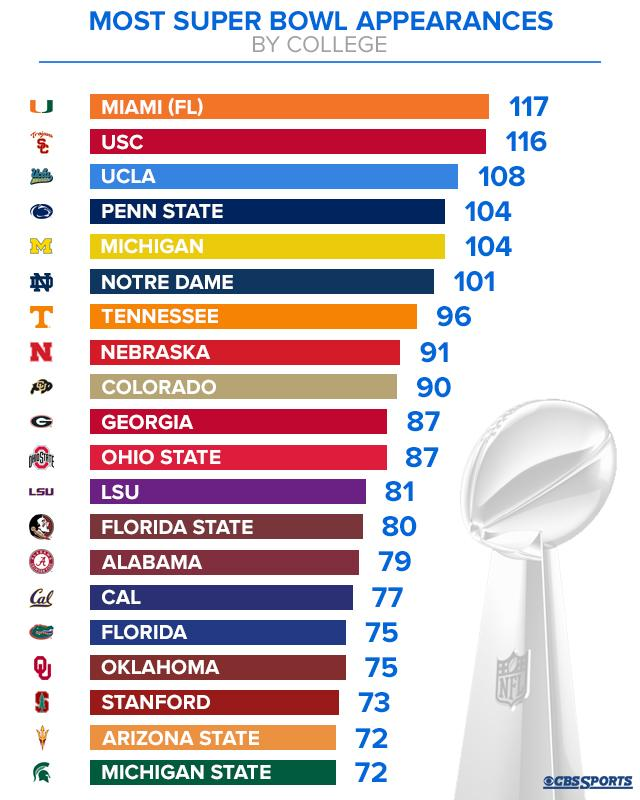Indicate a few pertinent items in this graphic. UCLA has made the third highest number of Super Bowl appearances. A college named Arizona State is mentioned in the second last row of the list. The name of the college that is mentioned seventh in the list is Tennessee. Nine colleges have made fewer than 85 Super Bowl appearances. There are six colleges that have made 100 or more Super Bowl appearances. 